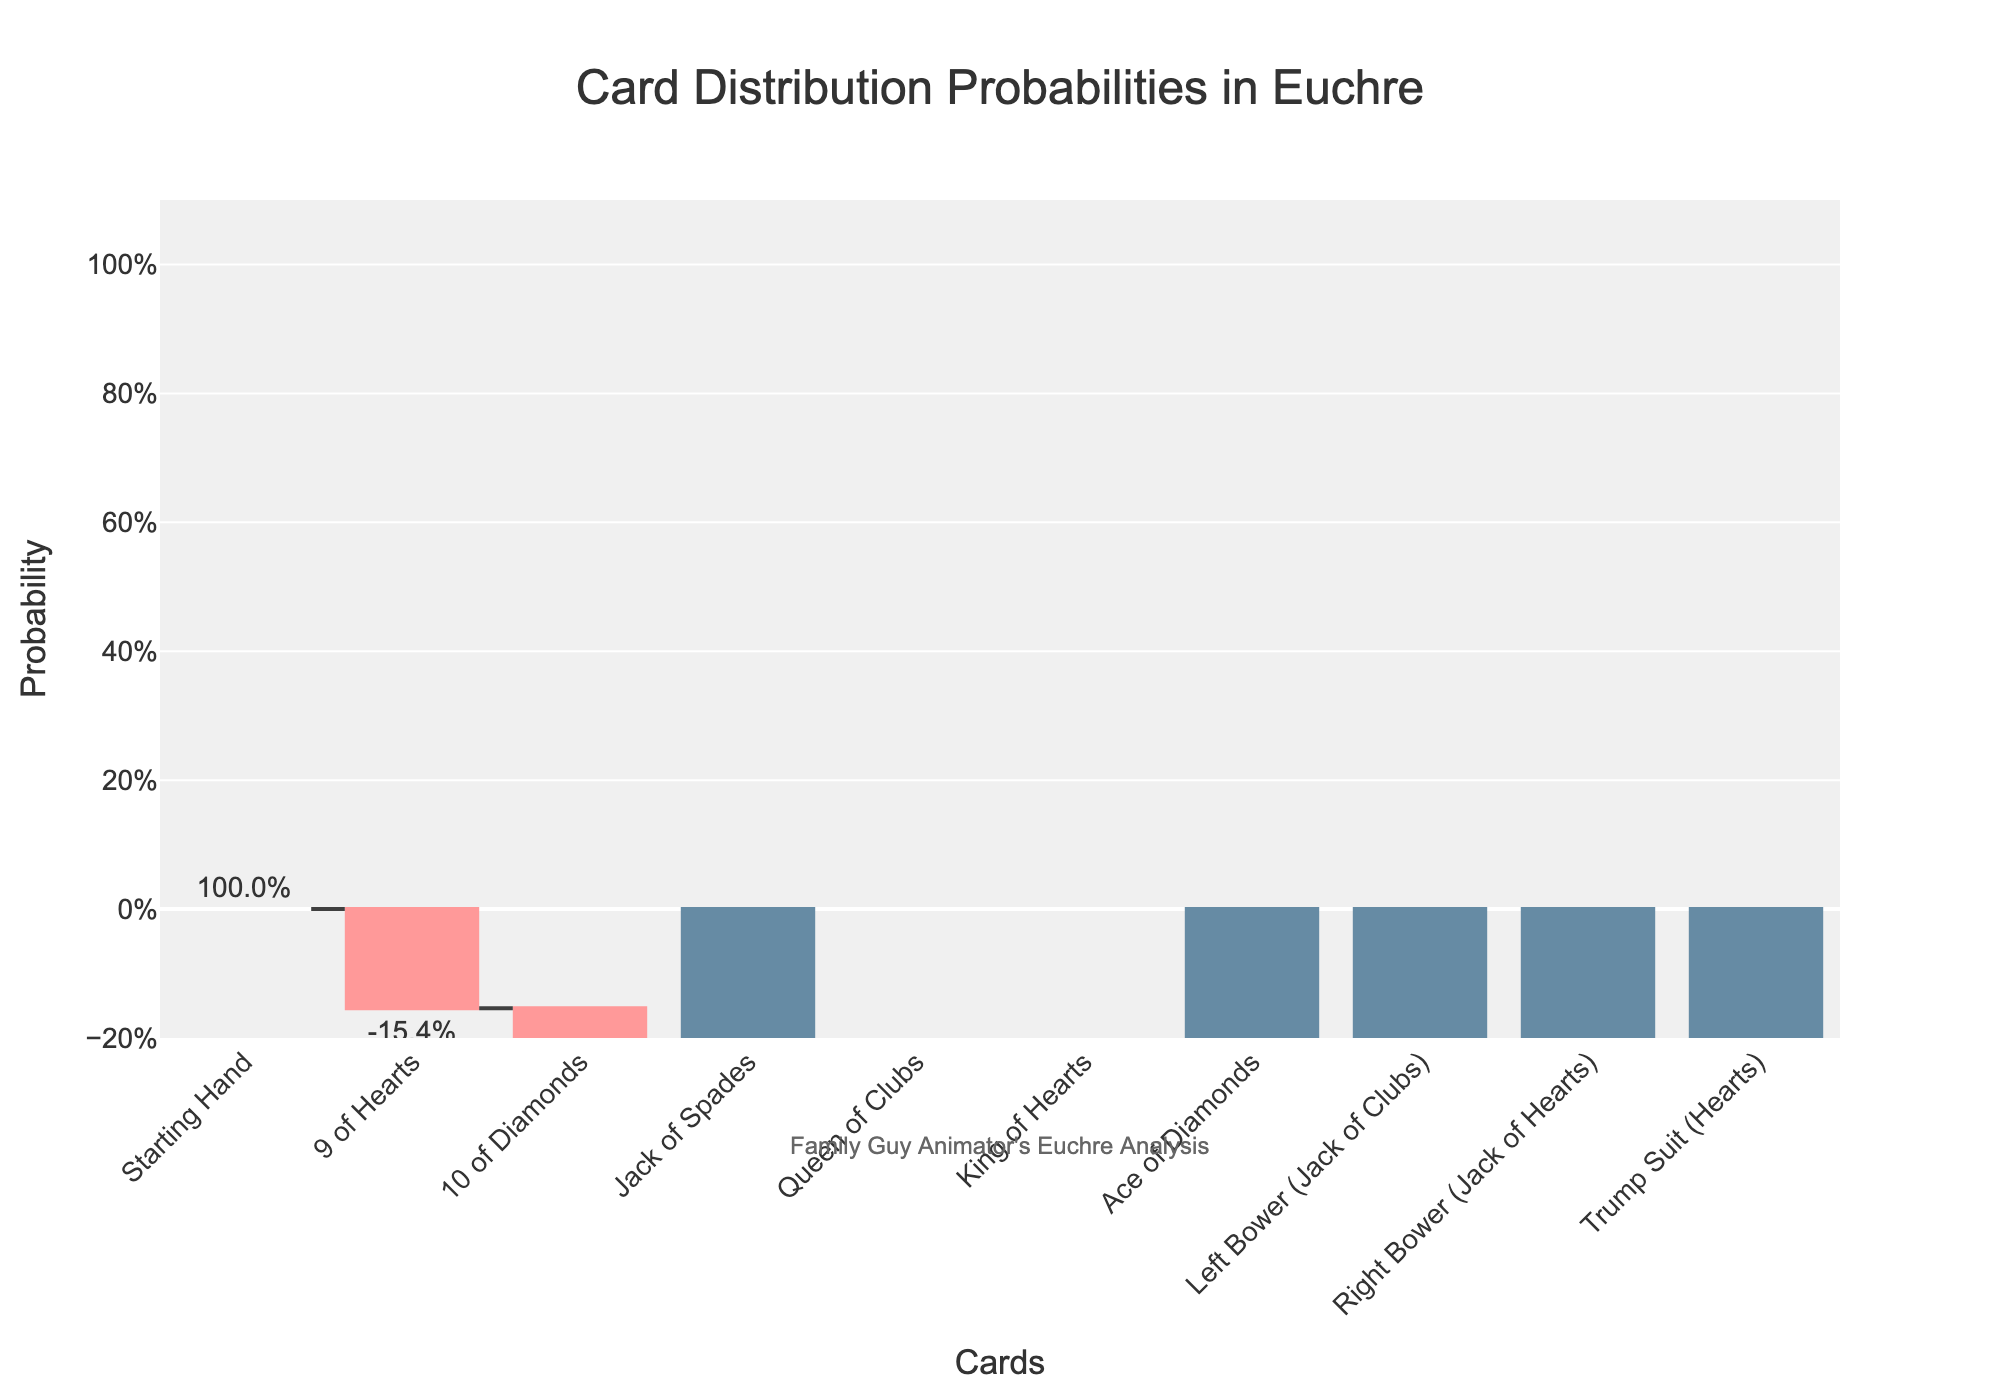What is the title of the chart? The title is displayed at the top center of the chart and reads "Card Distribution Probabilities in Euchre".
Answer: Card Distribution Probabilities in Euchre Which card has the highest positive probability contribution and what is its value? The highest positive probability contribution is represented by the tallest green bar, which corresponds to the Right Bower (Jack of Hearts) card. The value shown outside the bar is "30.8%".
Answer: Right Bower (Jack of Hearts), 0.308 How many cards have a negative probability contribution? The bars with negative contributions are colored red. Counting these red bars, there are 4 negative contributions: 9 of Hearts, 10 of Diamonds, Queen of Clubs, and King of Hearts.
Answer: 4 What is the total probability for the Trump Suit after accounting for individual card contributions? The total probability for the Trump Suit (Hearts) is represented by the total bar at the end of the chart, and it shows the value "92.3%". This accounts for the cumulative effect of all individual card contributions.
Answer: 0.923 Which card has the smallest positive probability contribution and how does it compare to the largest negative contribution? The smallest positive probability contribution comes from the Jack of Spades and Ace of Diamonds, both with values of "7.7%", while the largest negative contribution is from any of the cards with "-15.4%".
Answer: Jack of Spades and Ace of Diamonds, 0.077; Largest negative is -0.154 How does the initial starting hand probability compare to the final total for the Trump Suit (Hearts)? The initial starting hand probability is 100% (or 1.0) and the final total for the Trump Suit (Hearts) is 92.3%. Subtracting gives a decrease of 7.7% from the initial to the final.
Answer: Initial: 1.0, Final: 0.923, Decrease: 0.077 What percentage of the total probability does the Left Bower (Jack of Clubs) contribute? The Left Bower (Jack of Clubs) has a contribution of 23.1%. This is shown directly outside its corresponding green bar.
Answer: 23.1% Is the probability contribution of the Queen of Clubs positive or negative and what is its exact value? The Queen of Clubs has a negative probability contribution, as indicated by the red bar. The exact value is "-15.4%".
Answer: Negative, -0.154 